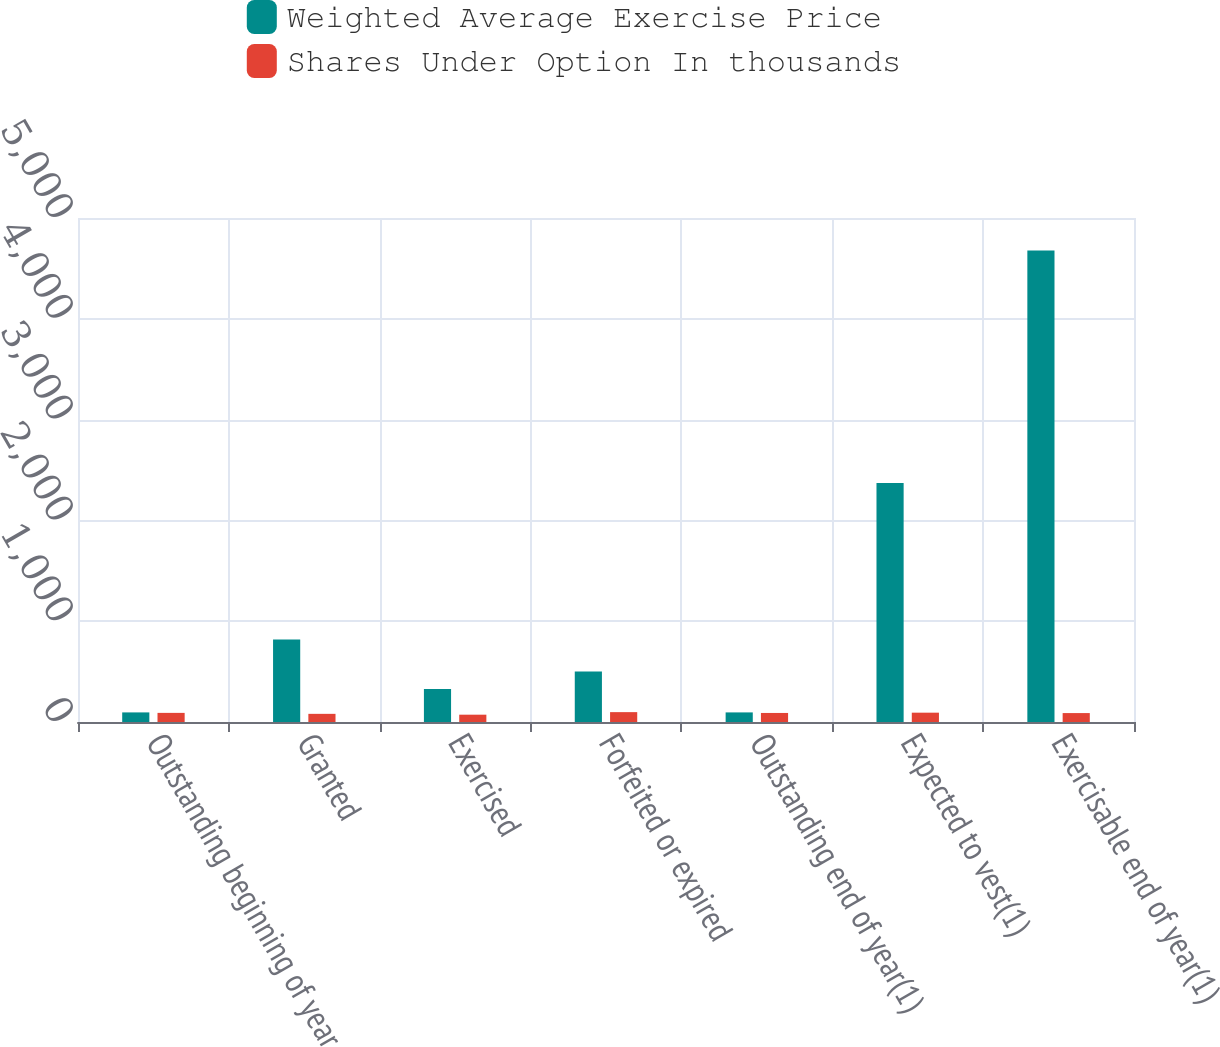Convert chart to OTSL. <chart><loc_0><loc_0><loc_500><loc_500><stacked_bar_chart><ecel><fcel>Outstanding beginning of year<fcel>Granted<fcel>Exercised<fcel>Forfeited or expired<fcel>Outstanding end of year(1)<fcel>Expected to vest(1)<fcel>Exercisable end of year(1)<nl><fcel>Weighted Average Exercise Price<fcel>95.19<fcel>819<fcel>327<fcel>502<fcel>95.19<fcel>2370<fcel>4678<nl><fcel>Shares Under Option In thousands<fcel>90.47<fcel>80.89<fcel>72.55<fcel>97.88<fcel>89.71<fcel>92.5<fcel>88.53<nl></chart> 